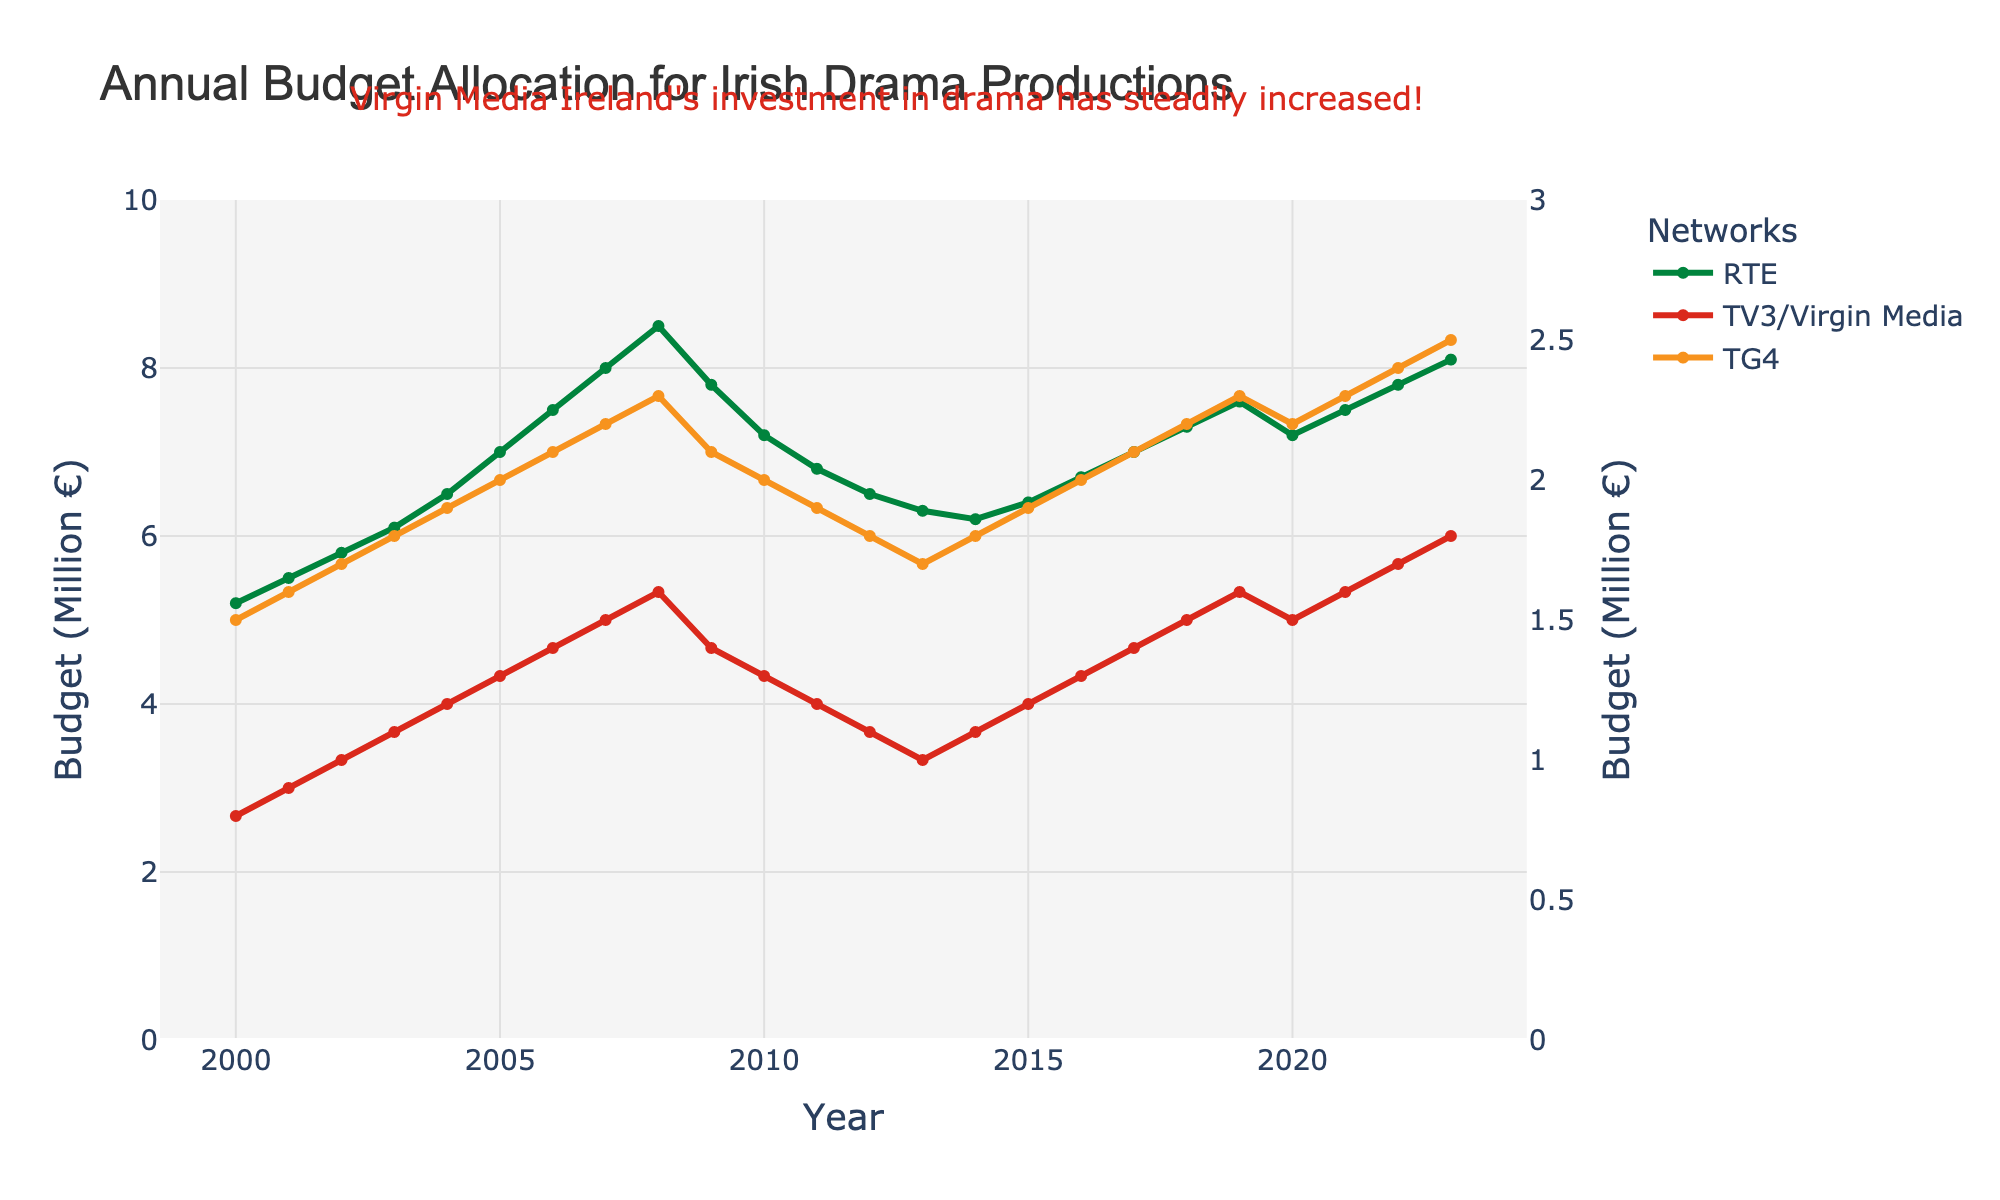What was the budget allocated by RTE in 2010? Locate the point corresponding to the year 2010 for RTE (green line) and read the y-axis value where it intersects.
Answer: 7.2 million € Which network saw the most significant increase in budget allocation over the entire period? Compare the initial and final budget values for RTE, TV3/Virgin Media, and TG4. RTE increased from 5.2 to 8.1, TV3/Virgin Media from 0.8 to 1.8, and TG4 from 1.5 to 2.5 million €. The increase for RTE is 2.9 million €, for TV3/Virgin Media it is 1.0 million €, and for TG4 it is 1.0 million €. Thus, RTE had the most significant increase.
Answer: RTE In which year did the budget for RTE peak and what was the value? Observe the green line and identify the highest point; the year corresponding to this point is where the peak occurs. The peak value is also the y-axis value at this point.
Answer: 2008, 8.5 million € How did the budget allocation of TG4 in 2009 compare to its budget in 2000? Identify the y-axis values where the orange line intersects for the years 2000 and 2009: 1.5 and 2.1 respectively. Calculate the difference between these values.
Answer: Increase by 0.6 million € What is the average budget allocation of TV3/Virgin Media over the given period? Sum the budget values of TV3/Virgin Media from 2000 to 2023 and divide by the number of years, which is 24. The values are: 0.8 + 0.9 + 1.0 + 1.1 + 1.2 + 1.3 + 1.4 + 1.5 + 1.6 + 1.4 + 1.3 + 1.2 + 1.1 + 1.0 + 1.1 + 1.2 + 1.3 + 1.4 + 1.5 + 1.5 + 1.6 + 1.7 + 1.8. Summing these gives 34.8. The average is 34.8 / 24.
Answer: 1.45 million € Which year showed a decline in budget allocation for RTE by the largest margin compared to the previous year? Observe the green line for any decreasing trend. The largest year-to-year decline is from 2008 to 2009, where the budget decreased from 8.5 to 7.8 million €, a decline of 0.7 million €.
Answer: 2009 What was the combined budget allocation for all three networks in 2023? Sum the budget values for RTE (8.1), TV3/Virgin Media (1.8), and TG4 (2.5) in the year 2023. The combined budget is 8.1 + 1.8 + 2.5 = 12.4 million €.
Answer: 12.4 million € Which network had the most stable budget allocation over the years? Examine the lines on the graph. The line for TV3/Virgin Media (red) shows the most gradual and consistent increase without significant fluctuations compared to RTE and TG4.
Answer: TV3/Virgin Media How does the budget allocation for RTE in 2023 compare to that of TV3/Virgin Media and TG4 combined? For 2023, add the values of TV3/Virgin Media (1.8) and TG4 (2.5) to get their combined budget: 4.3 million €. Compare this to the budget of RTE for the same year, which is 8.1 million €.
Answer: RTE is higher by 3.8 million € From 2007 to 2012, did the budget allocation for TG4 increase, decrease, or remain stable? Observe the trend of the orange line from 2007 (2.2) to 2012 (1.8). Since the value decreases during this period, the budget allocation for TG4 decreased.
Answer: Decrease 